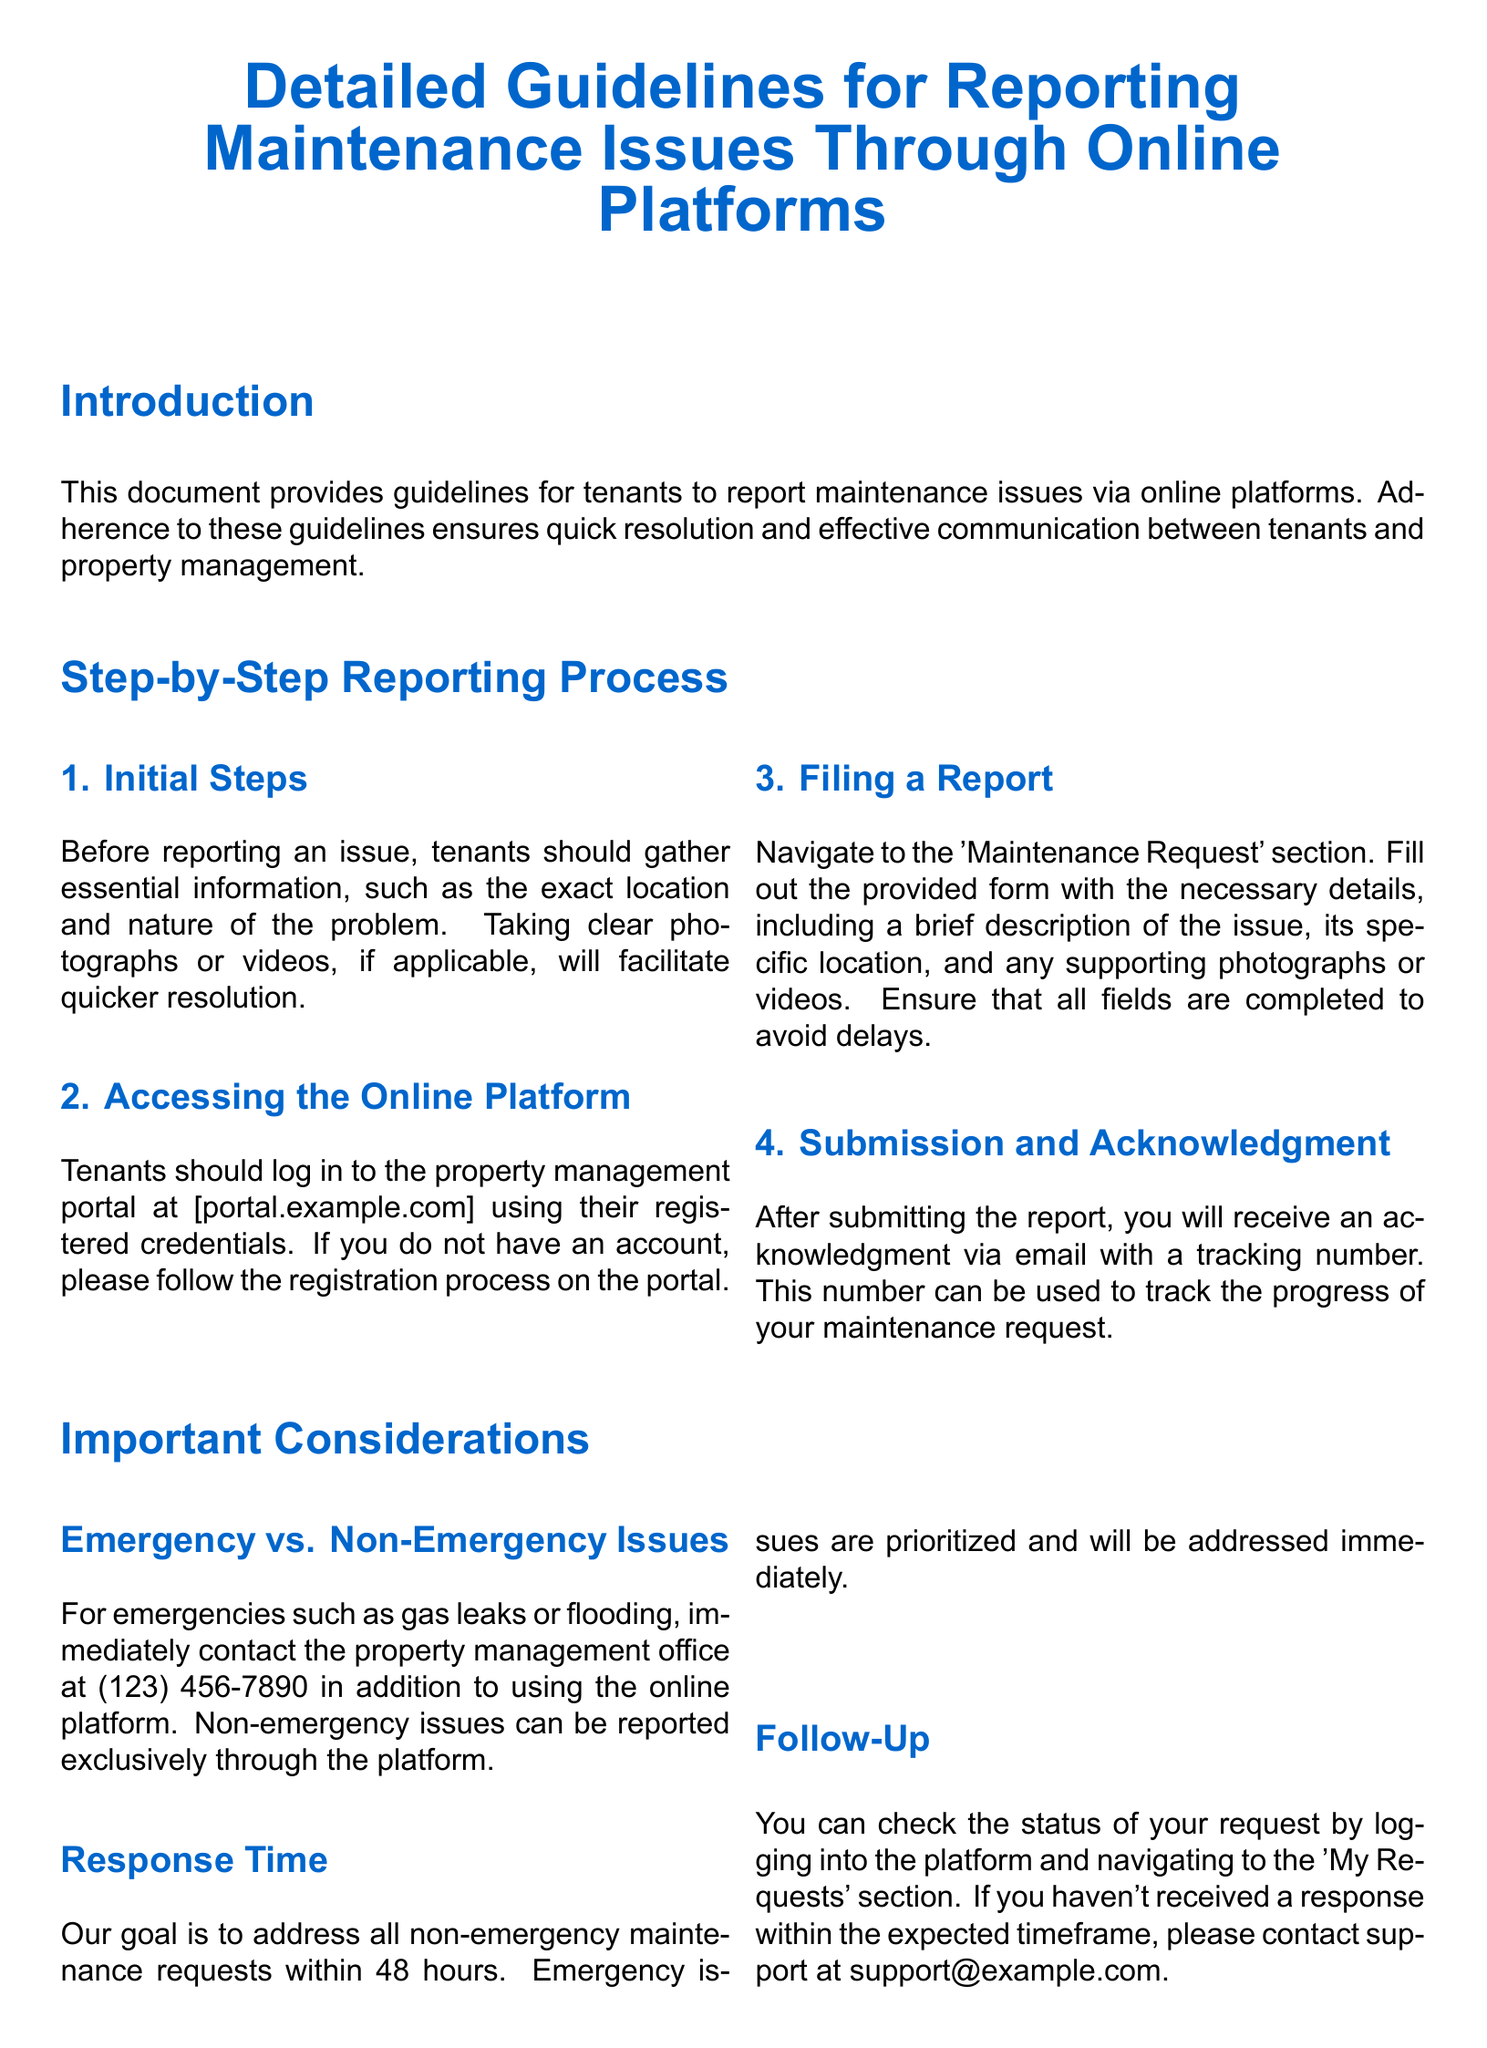What is the main purpose of the document? The document provides guidelines for tenants to report maintenance issues via online platforms.
Answer: Guidelines for reporting maintenance issues What is the website tenants should access? The document specifies the portal where tenants can log in to report issues.
Answer: portal.example.com What should tenants do before reporting an issue? Essential information includes the location and nature of the problem, as well as any photographs.
Answer: Gather essential information What is the response time for non-emergency requests? The goal for addressing non-emergency requests is specified in the document.
Answer: 48 hours What should tenants do for emergency situations? Tenants are instructed to contact property management directly in case of emergencies.
Answer: Contact the property management office What type of issues can be reported only through the online platform? The document differentiates between emergency and non-emergency issues regarding reporting methods.
Answer: Non-emergency issues How can tenants check the status of their requests? The process for checking request status is detailed in the document.
Answer: Log into the platform What should be avoided in communication? Respectful communication is emphasized, and specific behaviors are discouraged.
Answer: Offensive language What kind of information is safeguarded under data privacy? The document states that personal information is used solely for maintenance requests.
Answer: Personal information 